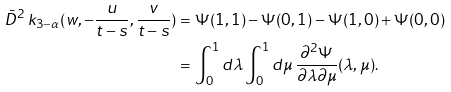Convert formula to latex. <formula><loc_0><loc_0><loc_500><loc_500>\bar { D } ^ { 2 } \, k _ { 3 - \alpha } ( w , - \frac { u } { t - s } , \frac { v } { t - s } ) & = \Psi ( 1 , 1 ) - \Psi ( 0 , 1 ) - \Psi ( 1 , 0 ) + \Psi ( 0 , 0 ) \\ & = \int ^ { 1 } _ { 0 } d \lambda \int _ { 0 } ^ { 1 } d \mu \, \frac { \partial ^ { 2 } \Psi } { \partial \lambda \partial \mu } ( \lambda , \mu ) .</formula> 